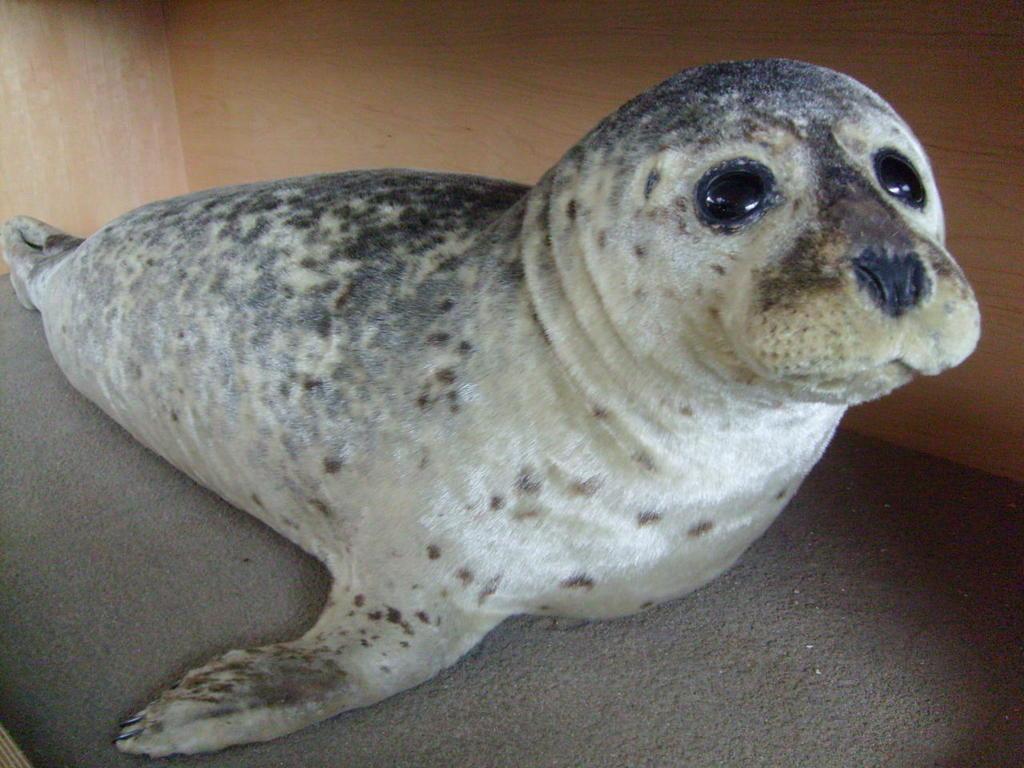Describe this image in one or two sentences. In this image, I can see a harbor seal. In the background, that looks like a wooden wall. 